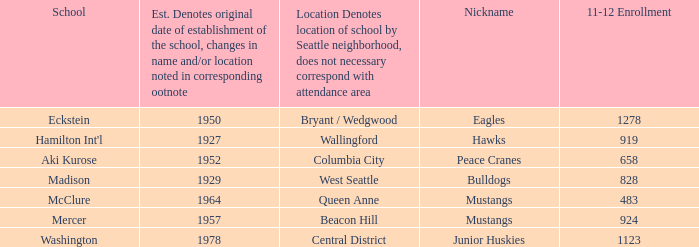Name the minimum 11-12 enrollment for washington school 1123.0. 